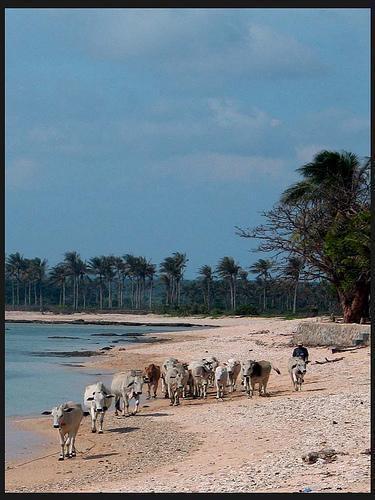How many surfaces can be seen?
Give a very brief answer. 2. How many sheep are in this picture?
Give a very brief answer. 0. 